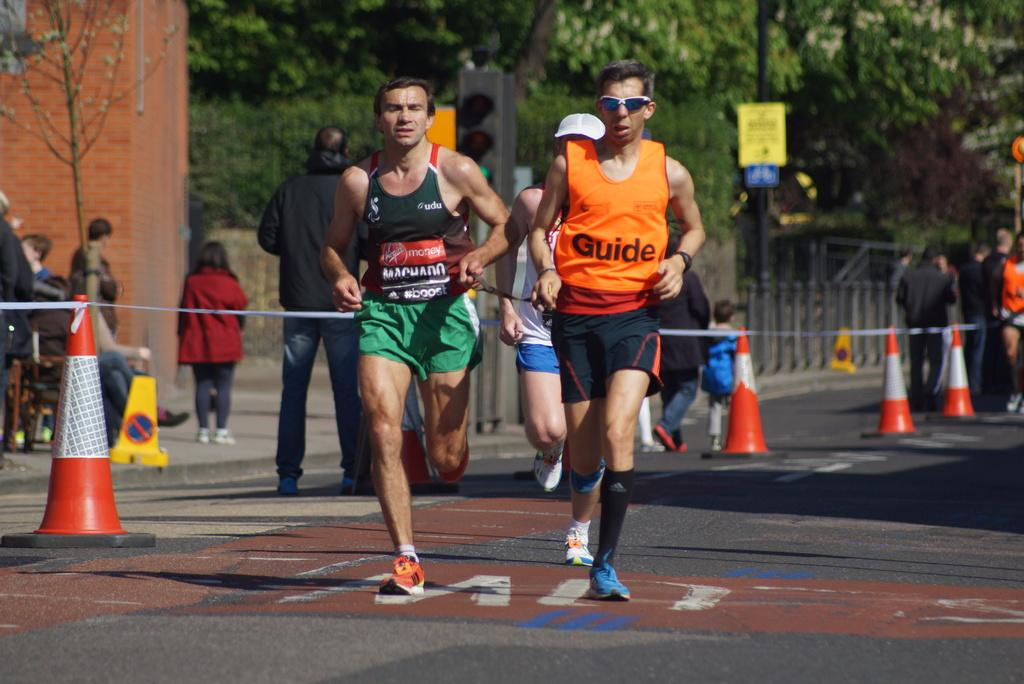<image>
Summarize the visual content of the image. The advertisement on the left runner is from virgin mobile 